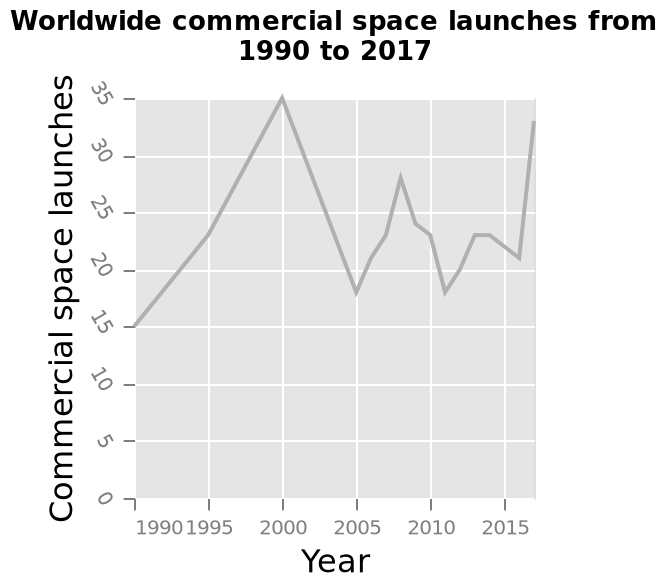<image>
What happened to the number of launches from 2000 to 2005?  There was a large decrease in the number of launches from 35 to 18 between 2000 and 2005. 